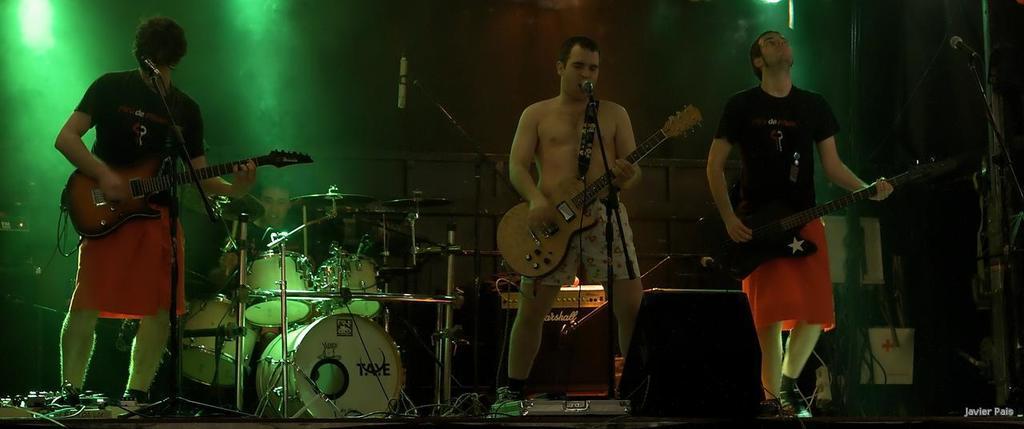In one or two sentences, can you explain what this image depicts? In this there are the three persons standing on the floor and playing a music and holding a guitar on his hand and there are some musical instruments kept on the floor,on the middle there is a person sit in front of the the musical instrument and left side there are the some lights visible. 